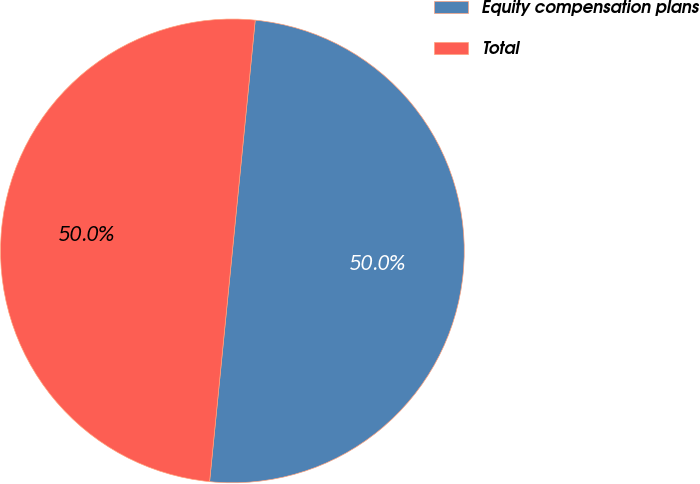Convert chart. <chart><loc_0><loc_0><loc_500><loc_500><pie_chart><fcel>Equity compensation plans<fcel>Total<nl><fcel>50.0%<fcel>50.0%<nl></chart> 